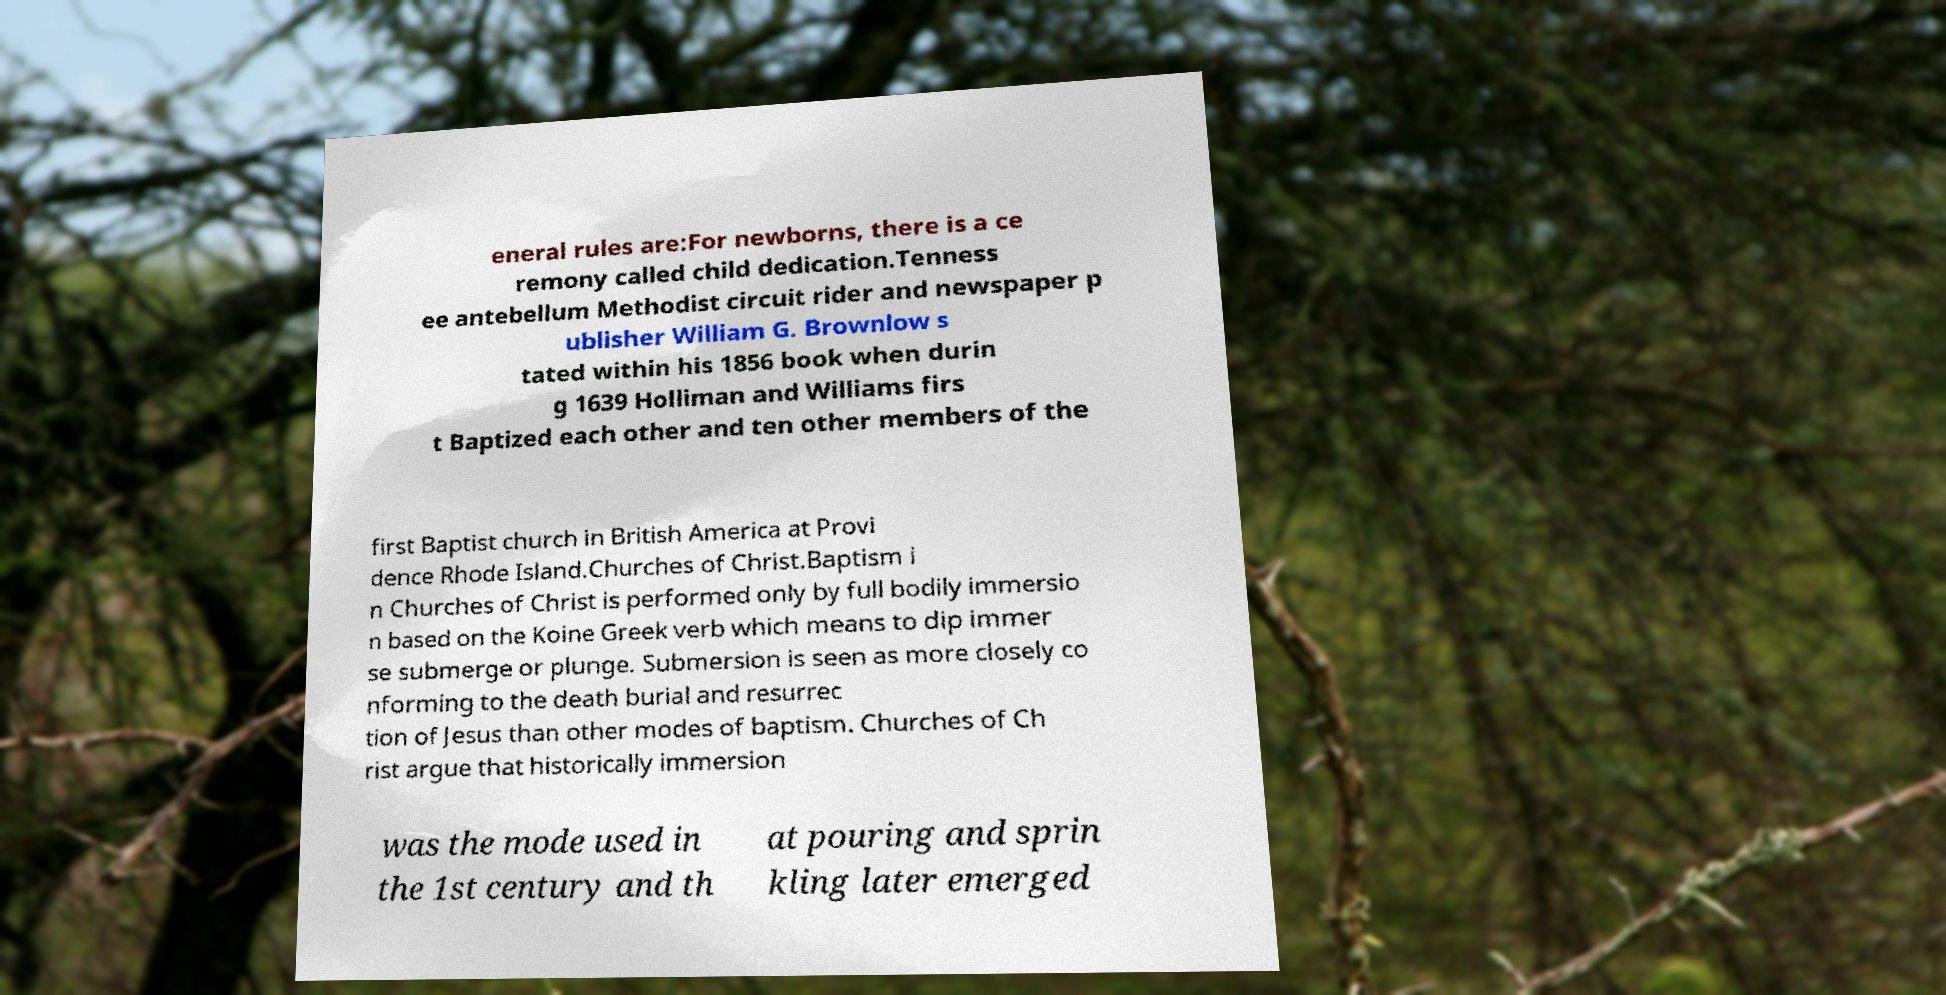Could you assist in decoding the text presented in this image and type it out clearly? eneral rules are:For newborns, there is a ce remony called child dedication.Tenness ee antebellum Methodist circuit rider and newspaper p ublisher William G. Brownlow s tated within his 1856 book when durin g 1639 Holliman and Williams firs t Baptized each other and ten other members of the first Baptist church in British America at Provi dence Rhode Island.Churches of Christ.Baptism i n Churches of Christ is performed only by full bodily immersio n based on the Koine Greek verb which means to dip immer se submerge or plunge. Submersion is seen as more closely co nforming to the death burial and resurrec tion of Jesus than other modes of baptism. Churches of Ch rist argue that historically immersion was the mode used in the 1st century and th at pouring and sprin kling later emerged 